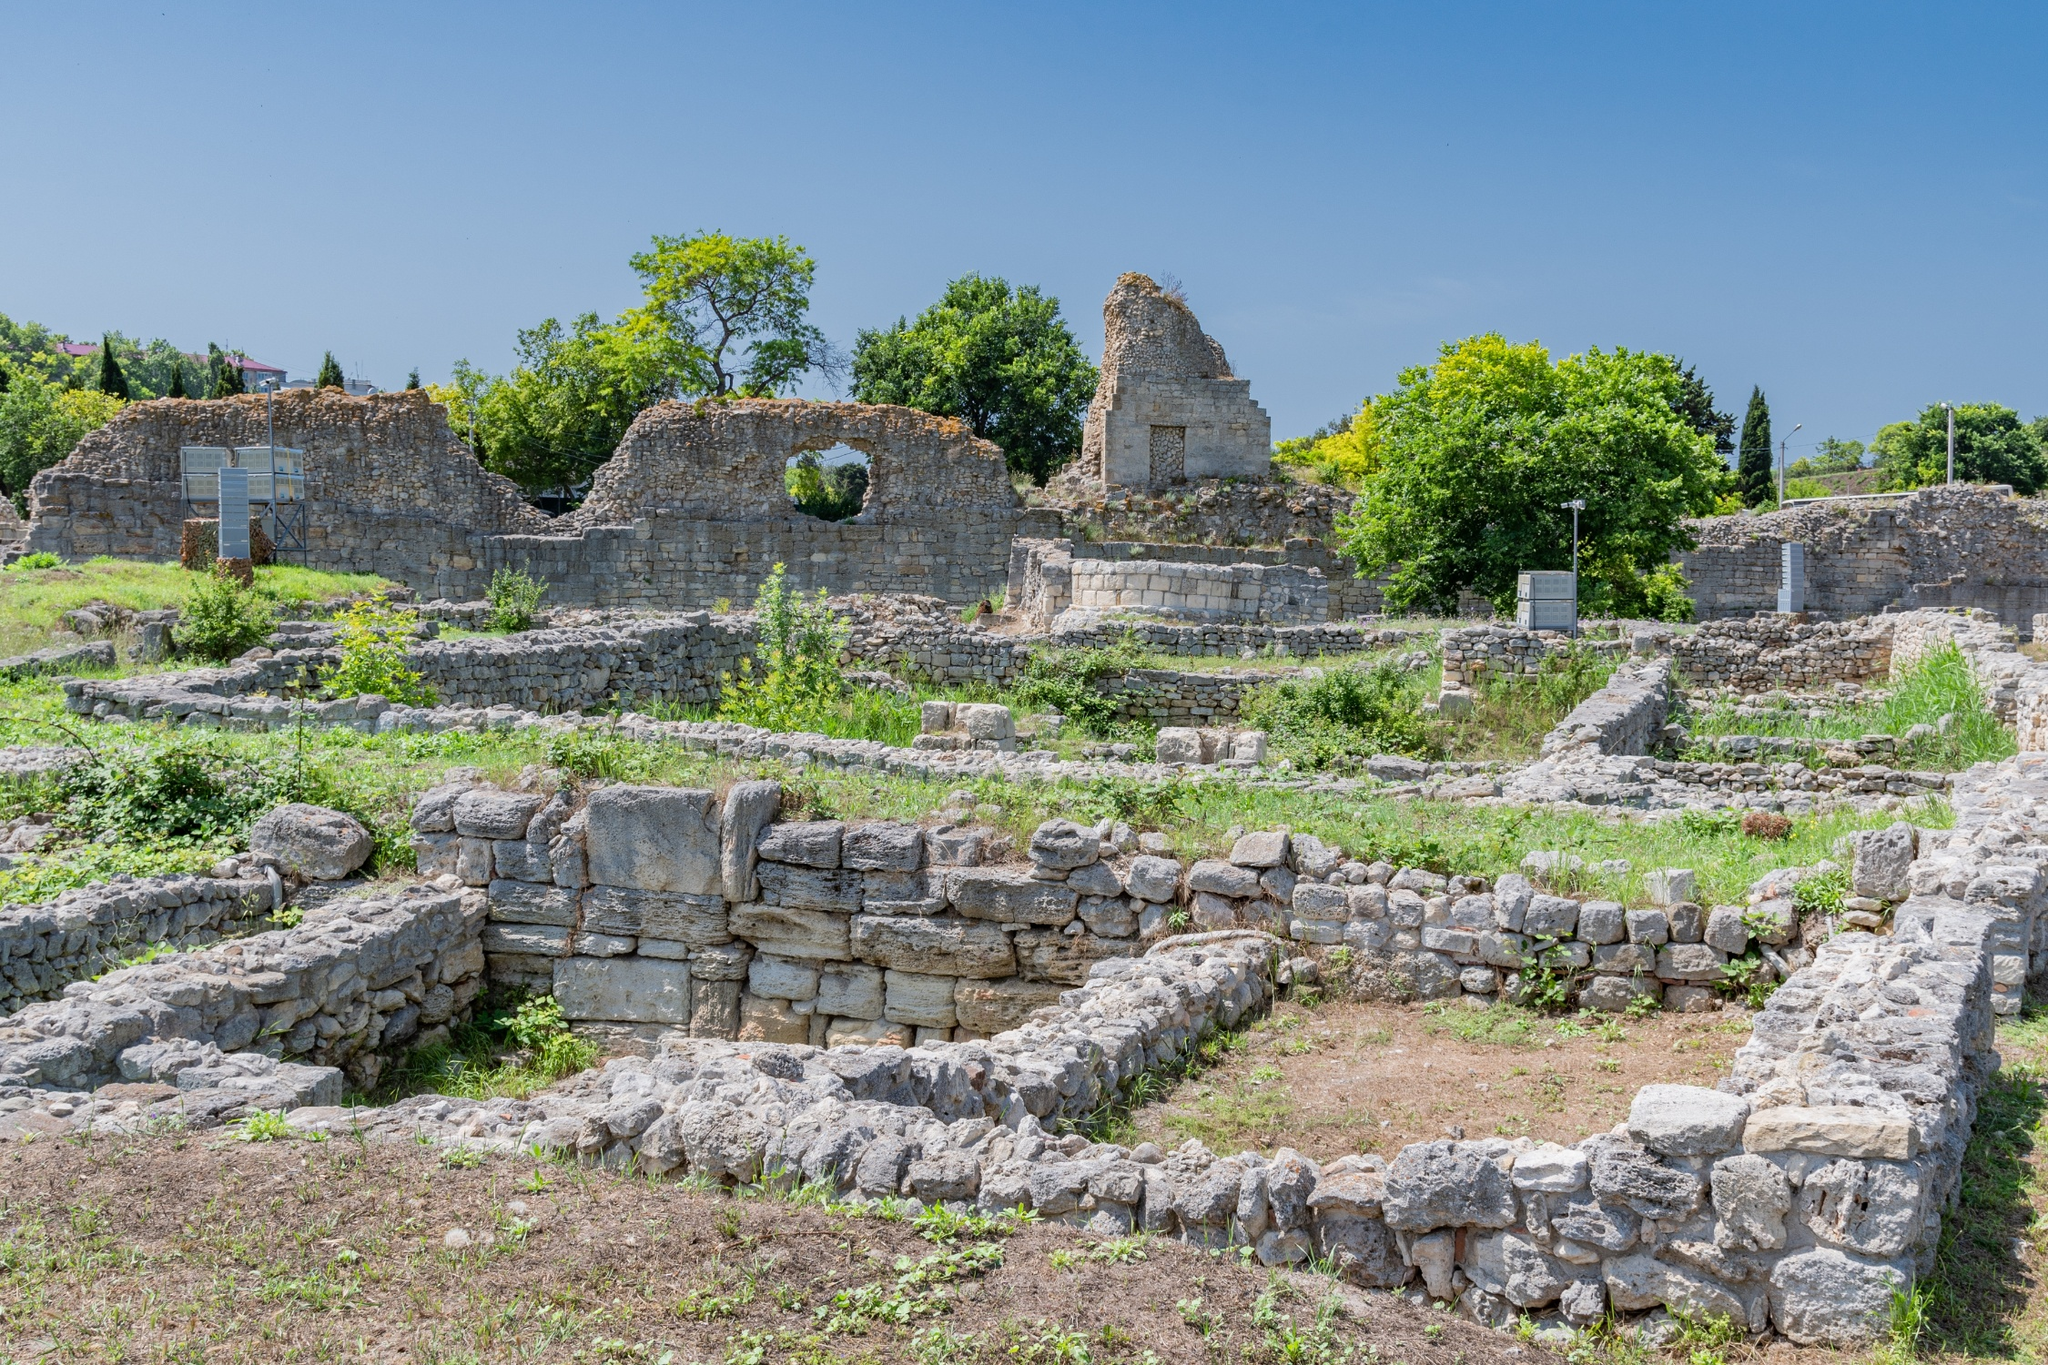What does the architecture tell us about the technological capabilities of this civilization? The architecture of these ruins reveals a great deal about the technological prowess of the civilization that constructed them. The use of large stone blocks and the intricate construction techniques required to build durable walls, doorways, and windows demonstrate a high level of skill and engineering knowledge. The ability to design and erect substantial and resilient structures that have stood the test of time points to advanced stone masonry and architectural planning. The overall layout suggests they had considerable knowledge in urban planning, ensuring connectivity and function within the city's infrastructure. Imagine a festival day in this city. What activities might have been there? On a festival day, the city would transform into a hub of jubilant activity and celebration. The streets would be adorned with decorations, and markets would overflow with stalls selling festive goods, exotic spices, and colorful fabrics. There would likely be processions featuring musicians, dancers, and possibly even acrobats performing for the crowds. Temples or religious buildings within the city might conduct special ceremonies or rituals, accompanied by the sound of chants and the scent of incense wafting through the air. Public squares would be bustling with games, food stalls offering a variety of delicacies, and people engaging in lively conversations and merriments. It was perhaps a time for the community to come together, enjoying a break from their daily routines to celebrate shared traditions and enjoy communal harmony. 